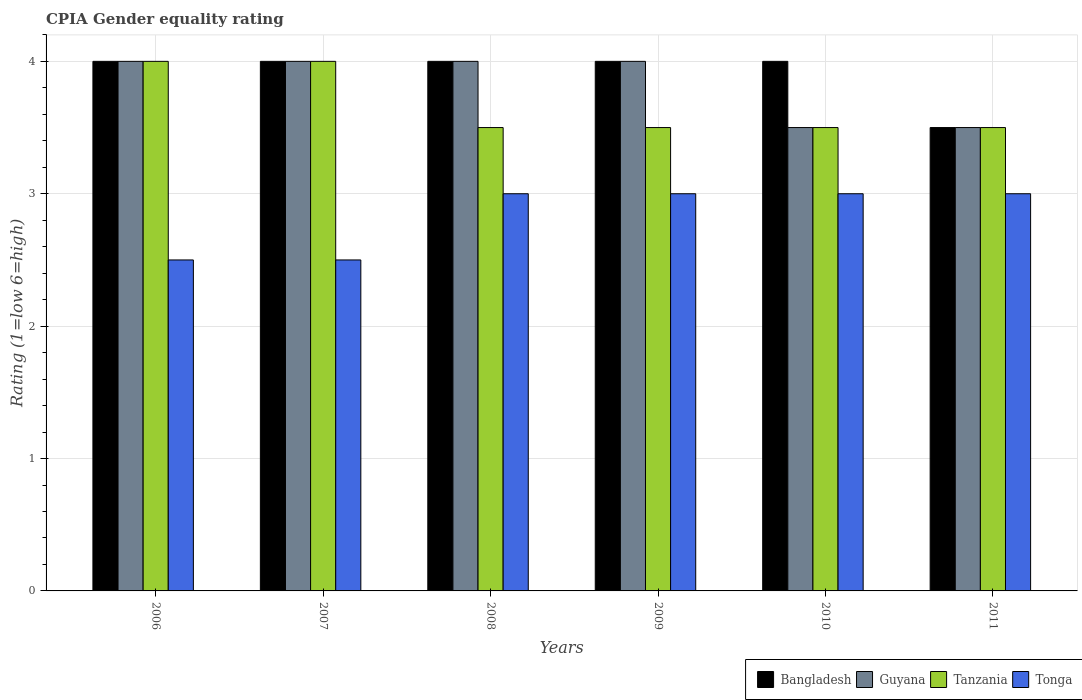Are the number of bars on each tick of the X-axis equal?
Give a very brief answer. Yes. What is the CPIA rating in Bangladesh in 2006?
Keep it short and to the point. 4. Across all years, what is the maximum CPIA rating in Guyana?
Provide a short and direct response. 4. Across all years, what is the minimum CPIA rating in Guyana?
Keep it short and to the point. 3.5. In which year was the CPIA rating in Guyana maximum?
Ensure brevity in your answer.  2006. What is the total CPIA rating in Tanzania in the graph?
Provide a short and direct response. 22. What is the difference between the CPIA rating in Guyana in 2006 and that in 2011?
Offer a terse response. 0.5. What is the difference between the CPIA rating in Guyana in 2008 and the CPIA rating in Tonga in 2009?
Offer a very short reply. 1. What is the average CPIA rating in Guyana per year?
Give a very brief answer. 3.83. In the year 2008, what is the difference between the CPIA rating in Bangladesh and CPIA rating in Tonga?
Offer a very short reply. 1. What is the ratio of the CPIA rating in Tonga in 2010 to that in 2011?
Offer a very short reply. 1. Is the difference between the CPIA rating in Bangladesh in 2008 and 2010 greater than the difference between the CPIA rating in Tonga in 2008 and 2010?
Provide a short and direct response. No. Is the sum of the CPIA rating in Guyana in 2006 and 2008 greater than the maximum CPIA rating in Tanzania across all years?
Your answer should be compact. Yes. What does the 4th bar from the left in 2006 represents?
Make the answer very short. Tonga. What does the 3rd bar from the right in 2009 represents?
Your response must be concise. Guyana. Is it the case that in every year, the sum of the CPIA rating in Guyana and CPIA rating in Bangladesh is greater than the CPIA rating in Tanzania?
Provide a succinct answer. Yes. How many bars are there?
Your answer should be very brief. 24. How many years are there in the graph?
Your answer should be very brief. 6. What is the difference between two consecutive major ticks on the Y-axis?
Give a very brief answer. 1. Does the graph contain any zero values?
Your answer should be compact. No. Does the graph contain grids?
Make the answer very short. Yes. Where does the legend appear in the graph?
Give a very brief answer. Bottom right. How many legend labels are there?
Offer a very short reply. 4. How are the legend labels stacked?
Your answer should be very brief. Horizontal. What is the title of the graph?
Your answer should be very brief. CPIA Gender equality rating. Does "Turkey" appear as one of the legend labels in the graph?
Your response must be concise. No. What is the label or title of the X-axis?
Your answer should be very brief. Years. What is the Rating (1=low 6=high) in Bangladesh in 2006?
Provide a succinct answer. 4. What is the Rating (1=low 6=high) in Guyana in 2006?
Ensure brevity in your answer.  4. What is the Rating (1=low 6=high) in Tonga in 2006?
Your answer should be compact. 2.5. What is the Rating (1=low 6=high) in Bangladesh in 2007?
Make the answer very short. 4. What is the Rating (1=low 6=high) in Guyana in 2007?
Your response must be concise. 4. What is the Rating (1=low 6=high) of Tonga in 2007?
Give a very brief answer. 2.5. What is the Rating (1=low 6=high) of Guyana in 2008?
Provide a short and direct response. 4. What is the Rating (1=low 6=high) of Guyana in 2009?
Your response must be concise. 4. What is the Rating (1=low 6=high) in Tanzania in 2010?
Provide a short and direct response. 3.5. What is the Rating (1=low 6=high) of Guyana in 2011?
Provide a succinct answer. 3.5. What is the Rating (1=low 6=high) of Tanzania in 2011?
Keep it short and to the point. 3.5. What is the Rating (1=low 6=high) in Tonga in 2011?
Provide a short and direct response. 3. Across all years, what is the maximum Rating (1=low 6=high) in Tonga?
Make the answer very short. 3. Across all years, what is the minimum Rating (1=low 6=high) in Guyana?
Make the answer very short. 3.5. What is the total Rating (1=low 6=high) of Bangladesh in the graph?
Offer a terse response. 23.5. What is the total Rating (1=low 6=high) of Guyana in the graph?
Offer a terse response. 23. What is the difference between the Rating (1=low 6=high) of Bangladesh in 2006 and that in 2007?
Offer a terse response. 0. What is the difference between the Rating (1=low 6=high) in Guyana in 2006 and that in 2007?
Give a very brief answer. 0. What is the difference between the Rating (1=low 6=high) in Tonga in 2006 and that in 2007?
Your answer should be very brief. 0. What is the difference between the Rating (1=low 6=high) in Bangladesh in 2006 and that in 2009?
Provide a succinct answer. 0. What is the difference between the Rating (1=low 6=high) of Guyana in 2006 and that in 2009?
Offer a terse response. 0. What is the difference between the Rating (1=low 6=high) in Tanzania in 2006 and that in 2009?
Keep it short and to the point. 0.5. What is the difference between the Rating (1=low 6=high) of Bangladesh in 2006 and that in 2010?
Your response must be concise. 0. What is the difference between the Rating (1=low 6=high) of Guyana in 2006 and that in 2010?
Offer a very short reply. 0.5. What is the difference between the Rating (1=low 6=high) in Tanzania in 2007 and that in 2009?
Ensure brevity in your answer.  0.5. What is the difference between the Rating (1=low 6=high) in Tanzania in 2007 and that in 2010?
Make the answer very short. 0.5. What is the difference between the Rating (1=low 6=high) in Tonga in 2007 and that in 2010?
Make the answer very short. -0.5. What is the difference between the Rating (1=low 6=high) in Bangladesh in 2007 and that in 2011?
Give a very brief answer. 0.5. What is the difference between the Rating (1=low 6=high) of Guyana in 2007 and that in 2011?
Your answer should be compact. 0.5. What is the difference between the Rating (1=low 6=high) in Guyana in 2008 and that in 2009?
Your response must be concise. 0. What is the difference between the Rating (1=low 6=high) in Tonga in 2008 and that in 2009?
Give a very brief answer. 0. What is the difference between the Rating (1=low 6=high) in Guyana in 2008 and that in 2010?
Provide a short and direct response. 0.5. What is the difference between the Rating (1=low 6=high) in Tanzania in 2008 and that in 2010?
Provide a succinct answer. 0. What is the difference between the Rating (1=low 6=high) in Bangladesh in 2008 and that in 2011?
Provide a succinct answer. 0.5. What is the difference between the Rating (1=low 6=high) in Tonga in 2008 and that in 2011?
Your response must be concise. 0. What is the difference between the Rating (1=low 6=high) in Bangladesh in 2009 and that in 2010?
Ensure brevity in your answer.  0. What is the difference between the Rating (1=low 6=high) in Guyana in 2009 and that in 2010?
Offer a terse response. 0.5. What is the difference between the Rating (1=low 6=high) in Tanzania in 2009 and that in 2010?
Your response must be concise. 0. What is the difference between the Rating (1=low 6=high) in Tonga in 2009 and that in 2010?
Offer a very short reply. 0. What is the difference between the Rating (1=low 6=high) of Guyana in 2009 and that in 2011?
Provide a succinct answer. 0.5. What is the difference between the Rating (1=low 6=high) of Tonga in 2009 and that in 2011?
Offer a very short reply. 0. What is the difference between the Rating (1=low 6=high) in Bangladesh in 2010 and that in 2011?
Give a very brief answer. 0.5. What is the difference between the Rating (1=low 6=high) in Tanzania in 2010 and that in 2011?
Your response must be concise. 0. What is the difference between the Rating (1=low 6=high) in Bangladesh in 2006 and the Rating (1=low 6=high) in Guyana in 2007?
Provide a short and direct response. 0. What is the difference between the Rating (1=low 6=high) in Bangladesh in 2006 and the Rating (1=low 6=high) in Tanzania in 2007?
Your answer should be compact. 0. What is the difference between the Rating (1=low 6=high) in Guyana in 2006 and the Rating (1=low 6=high) in Tanzania in 2007?
Keep it short and to the point. 0. What is the difference between the Rating (1=low 6=high) in Guyana in 2006 and the Rating (1=low 6=high) in Tonga in 2007?
Offer a terse response. 1.5. What is the difference between the Rating (1=low 6=high) of Bangladesh in 2006 and the Rating (1=low 6=high) of Guyana in 2008?
Give a very brief answer. 0. What is the difference between the Rating (1=low 6=high) of Bangladesh in 2006 and the Rating (1=low 6=high) of Tanzania in 2008?
Provide a short and direct response. 0.5. What is the difference between the Rating (1=low 6=high) of Bangladesh in 2006 and the Rating (1=low 6=high) of Tonga in 2008?
Keep it short and to the point. 1. What is the difference between the Rating (1=low 6=high) in Tanzania in 2006 and the Rating (1=low 6=high) in Tonga in 2008?
Make the answer very short. 1. What is the difference between the Rating (1=low 6=high) in Bangladesh in 2006 and the Rating (1=low 6=high) in Tanzania in 2009?
Provide a succinct answer. 0.5. What is the difference between the Rating (1=low 6=high) in Guyana in 2006 and the Rating (1=low 6=high) in Tonga in 2009?
Give a very brief answer. 1. What is the difference between the Rating (1=low 6=high) in Bangladesh in 2006 and the Rating (1=low 6=high) in Guyana in 2010?
Your answer should be compact. 0.5. What is the difference between the Rating (1=low 6=high) in Guyana in 2006 and the Rating (1=low 6=high) in Tonga in 2010?
Your response must be concise. 1. What is the difference between the Rating (1=low 6=high) in Tanzania in 2006 and the Rating (1=low 6=high) in Tonga in 2010?
Ensure brevity in your answer.  1. What is the difference between the Rating (1=low 6=high) in Bangladesh in 2006 and the Rating (1=low 6=high) in Tanzania in 2011?
Keep it short and to the point. 0.5. What is the difference between the Rating (1=low 6=high) of Bangladesh in 2007 and the Rating (1=low 6=high) of Guyana in 2008?
Ensure brevity in your answer.  0. What is the difference between the Rating (1=low 6=high) in Bangladesh in 2007 and the Rating (1=low 6=high) in Tanzania in 2008?
Make the answer very short. 0.5. What is the difference between the Rating (1=low 6=high) in Bangladesh in 2007 and the Rating (1=low 6=high) in Tonga in 2008?
Offer a very short reply. 1. What is the difference between the Rating (1=low 6=high) in Guyana in 2007 and the Rating (1=low 6=high) in Tanzania in 2008?
Your answer should be very brief. 0.5. What is the difference between the Rating (1=low 6=high) of Tanzania in 2007 and the Rating (1=low 6=high) of Tonga in 2008?
Offer a terse response. 1. What is the difference between the Rating (1=low 6=high) in Bangladesh in 2007 and the Rating (1=low 6=high) in Guyana in 2009?
Give a very brief answer. 0. What is the difference between the Rating (1=low 6=high) in Guyana in 2007 and the Rating (1=low 6=high) in Tanzania in 2009?
Ensure brevity in your answer.  0.5. What is the difference between the Rating (1=low 6=high) in Bangladesh in 2007 and the Rating (1=low 6=high) in Guyana in 2010?
Make the answer very short. 0.5. What is the difference between the Rating (1=low 6=high) of Bangladesh in 2007 and the Rating (1=low 6=high) of Tanzania in 2010?
Make the answer very short. 0.5. What is the difference between the Rating (1=low 6=high) in Bangladesh in 2007 and the Rating (1=low 6=high) in Tonga in 2010?
Offer a very short reply. 1. What is the difference between the Rating (1=low 6=high) of Guyana in 2007 and the Rating (1=low 6=high) of Tanzania in 2010?
Provide a short and direct response. 0.5. What is the difference between the Rating (1=low 6=high) in Tanzania in 2007 and the Rating (1=low 6=high) in Tonga in 2010?
Make the answer very short. 1. What is the difference between the Rating (1=low 6=high) of Bangladesh in 2007 and the Rating (1=low 6=high) of Tanzania in 2011?
Offer a terse response. 0.5. What is the difference between the Rating (1=low 6=high) in Bangladesh in 2007 and the Rating (1=low 6=high) in Tonga in 2011?
Your answer should be compact. 1. What is the difference between the Rating (1=low 6=high) of Tanzania in 2007 and the Rating (1=low 6=high) of Tonga in 2011?
Offer a very short reply. 1. What is the difference between the Rating (1=low 6=high) in Bangladesh in 2008 and the Rating (1=low 6=high) in Tanzania in 2009?
Offer a terse response. 0.5. What is the difference between the Rating (1=low 6=high) of Guyana in 2008 and the Rating (1=low 6=high) of Tanzania in 2009?
Give a very brief answer. 0.5. What is the difference between the Rating (1=low 6=high) in Tanzania in 2008 and the Rating (1=low 6=high) in Tonga in 2009?
Make the answer very short. 0.5. What is the difference between the Rating (1=low 6=high) in Guyana in 2008 and the Rating (1=low 6=high) in Tanzania in 2010?
Ensure brevity in your answer.  0.5. What is the difference between the Rating (1=low 6=high) in Bangladesh in 2008 and the Rating (1=low 6=high) in Guyana in 2011?
Your answer should be compact. 0.5. What is the difference between the Rating (1=low 6=high) in Bangladesh in 2008 and the Rating (1=low 6=high) in Tanzania in 2011?
Provide a succinct answer. 0.5. What is the difference between the Rating (1=low 6=high) in Tanzania in 2008 and the Rating (1=low 6=high) in Tonga in 2011?
Your answer should be compact. 0.5. What is the difference between the Rating (1=low 6=high) in Bangladesh in 2009 and the Rating (1=low 6=high) in Tonga in 2010?
Provide a succinct answer. 1. What is the difference between the Rating (1=low 6=high) in Tanzania in 2009 and the Rating (1=low 6=high) in Tonga in 2010?
Keep it short and to the point. 0.5. What is the difference between the Rating (1=low 6=high) in Bangladesh in 2009 and the Rating (1=low 6=high) in Tanzania in 2011?
Your answer should be compact. 0.5. What is the difference between the Rating (1=low 6=high) in Bangladesh in 2009 and the Rating (1=low 6=high) in Tonga in 2011?
Your response must be concise. 1. What is the difference between the Rating (1=low 6=high) in Guyana in 2009 and the Rating (1=low 6=high) in Tanzania in 2011?
Ensure brevity in your answer.  0.5. What is the difference between the Rating (1=low 6=high) in Guyana in 2009 and the Rating (1=low 6=high) in Tonga in 2011?
Your answer should be very brief. 1. What is the difference between the Rating (1=low 6=high) of Bangladesh in 2010 and the Rating (1=low 6=high) of Guyana in 2011?
Make the answer very short. 0.5. What is the difference between the Rating (1=low 6=high) in Bangladesh in 2010 and the Rating (1=low 6=high) in Tonga in 2011?
Your answer should be compact. 1. What is the difference between the Rating (1=low 6=high) of Guyana in 2010 and the Rating (1=low 6=high) of Tanzania in 2011?
Give a very brief answer. 0. What is the difference between the Rating (1=low 6=high) of Guyana in 2010 and the Rating (1=low 6=high) of Tonga in 2011?
Ensure brevity in your answer.  0.5. What is the difference between the Rating (1=low 6=high) of Tanzania in 2010 and the Rating (1=low 6=high) of Tonga in 2011?
Your response must be concise. 0.5. What is the average Rating (1=low 6=high) in Bangladesh per year?
Make the answer very short. 3.92. What is the average Rating (1=low 6=high) of Guyana per year?
Your answer should be very brief. 3.83. What is the average Rating (1=low 6=high) of Tanzania per year?
Ensure brevity in your answer.  3.67. What is the average Rating (1=low 6=high) in Tonga per year?
Your answer should be compact. 2.83. In the year 2006, what is the difference between the Rating (1=low 6=high) in Bangladesh and Rating (1=low 6=high) in Tanzania?
Make the answer very short. 0. In the year 2006, what is the difference between the Rating (1=low 6=high) of Guyana and Rating (1=low 6=high) of Tanzania?
Offer a terse response. 0. In the year 2006, what is the difference between the Rating (1=low 6=high) in Guyana and Rating (1=low 6=high) in Tonga?
Provide a succinct answer. 1.5. In the year 2006, what is the difference between the Rating (1=low 6=high) of Tanzania and Rating (1=low 6=high) of Tonga?
Your response must be concise. 1.5. In the year 2007, what is the difference between the Rating (1=low 6=high) of Guyana and Rating (1=low 6=high) of Tonga?
Make the answer very short. 1.5. In the year 2008, what is the difference between the Rating (1=low 6=high) in Bangladesh and Rating (1=low 6=high) in Tanzania?
Offer a very short reply. 0.5. In the year 2008, what is the difference between the Rating (1=low 6=high) of Bangladesh and Rating (1=low 6=high) of Tonga?
Provide a short and direct response. 1. In the year 2008, what is the difference between the Rating (1=low 6=high) in Guyana and Rating (1=low 6=high) in Tanzania?
Keep it short and to the point. 0.5. In the year 2009, what is the difference between the Rating (1=low 6=high) of Bangladesh and Rating (1=low 6=high) of Guyana?
Provide a short and direct response. 0. In the year 2009, what is the difference between the Rating (1=low 6=high) in Guyana and Rating (1=low 6=high) in Tonga?
Ensure brevity in your answer.  1. In the year 2009, what is the difference between the Rating (1=low 6=high) in Tanzania and Rating (1=low 6=high) in Tonga?
Give a very brief answer. 0.5. In the year 2010, what is the difference between the Rating (1=low 6=high) of Bangladesh and Rating (1=low 6=high) of Tanzania?
Offer a very short reply. 0.5. In the year 2010, what is the difference between the Rating (1=low 6=high) of Guyana and Rating (1=low 6=high) of Tanzania?
Offer a very short reply. 0. In the year 2010, what is the difference between the Rating (1=low 6=high) of Guyana and Rating (1=low 6=high) of Tonga?
Make the answer very short. 0.5. In the year 2010, what is the difference between the Rating (1=low 6=high) of Tanzania and Rating (1=low 6=high) of Tonga?
Provide a succinct answer. 0.5. In the year 2011, what is the difference between the Rating (1=low 6=high) in Guyana and Rating (1=low 6=high) in Tanzania?
Offer a very short reply. 0. In the year 2011, what is the difference between the Rating (1=low 6=high) in Tanzania and Rating (1=low 6=high) in Tonga?
Make the answer very short. 0.5. What is the ratio of the Rating (1=low 6=high) in Bangladesh in 2006 to that in 2007?
Offer a terse response. 1. What is the ratio of the Rating (1=low 6=high) in Tonga in 2006 to that in 2007?
Your answer should be very brief. 1. What is the ratio of the Rating (1=low 6=high) in Tonga in 2006 to that in 2009?
Your answer should be compact. 0.83. What is the ratio of the Rating (1=low 6=high) in Bangladesh in 2006 to that in 2011?
Your answer should be compact. 1.14. What is the ratio of the Rating (1=low 6=high) of Tonga in 2006 to that in 2011?
Provide a succinct answer. 0.83. What is the ratio of the Rating (1=low 6=high) of Bangladesh in 2007 to that in 2008?
Your response must be concise. 1. What is the ratio of the Rating (1=low 6=high) in Guyana in 2007 to that in 2008?
Provide a short and direct response. 1. What is the ratio of the Rating (1=low 6=high) in Tanzania in 2007 to that in 2008?
Your answer should be compact. 1.14. What is the ratio of the Rating (1=low 6=high) in Tonga in 2007 to that in 2008?
Your response must be concise. 0.83. What is the ratio of the Rating (1=low 6=high) in Bangladesh in 2007 to that in 2009?
Give a very brief answer. 1. What is the ratio of the Rating (1=low 6=high) of Guyana in 2007 to that in 2009?
Your response must be concise. 1. What is the ratio of the Rating (1=low 6=high) of Tonga in 2007 to that in 2009?
Your answer should be very brief. 0.83. What is the ratio of the Rating (1=low 6=high) of Guyana in 2007 to that in 2010?
Offer a very short reply. 1.14. What is the ratio of the Rating (1=low 6=high) in Tonga in 2007 to that in 2010?
Ensure brevity in your answer.  0.83. What is the ratio of the Rating (1=low 6=high) in Bangladesh in 2007 to that in 2011?
Provide a succinct answer. 1.14. What is the ratio of the Rating (1=low 6=high) of Guyana in 2007 to that in 2011?
Provide a succinct answer. 1.14. What is the ratio of the Rating (1=low 6=high) in Tanzania in 2007 to that in 2011?
Offer a very short reply. 1.14. What is the ratio of the Rating (1=low 6=high) in Tonga in 2007 to that in 2011?
Offer a terse response. 0.83. What is the ratio of the Rating (1=low 6=high) in Guyana in 2008 to that in 2009?
Your answer should be very brief. 1. What is the ratio of the Rating (1=low 6=high) of Tanzania in 2008 to that in 2009?
Your answer should be compact. 1. What is the ratio of the Rating (1=low 6=high) of Bangladesh in 2008 to that in 2010?
Offer a very short reply. 1. What is the ratio of the Rating (1=low 6=high) in Guyana in 2008 to that in 2010?
Your answer should be compact. 1.14. What is the ratio of the Rating (1=low 6=high) in Tonga in 2008 to that in 2010?
Ensure brevity in your answer.  1. What is the ratio of the Rating (1=low 6=high) of Bangladesh in 2008 to that in 2011?
Keep it short and to the point. 1.14. What is the ratio of the Rating (1=low 6=high) of Tanzania in 2008 to that in 2011?
Ensure brevity in your answer.  1. What is the ratio of the Rating (1=low 6=high) of Tonga in 2009 to that in 2010?
Give a very brief answer. 1. What is the ratio of the Rating (1=low 6=high) of Guyana in 2009 to that in 2011?
Offer a terse response. 1.14. What is the ratio of the Rating (1=low 6=high) of Tanzania in 2009 to that in 2011?
Offer a very short reply. 1. What is the ratio of the Rating (1=low 6=high) in Bangladesh in 2010 to that in 2011?
Keep it short and to the point. 1.14. What is the ratio of the Rating (1=low 6=high) in Guyana in 2010 to that in 2011?
Ensure brevity in your answer.  1. What is the ratio of the Rating (1=low 6=high) in Tanzania in 2010 to that in 2011?
Your response must be concise. 1. What is the difference between the highest and the second highest Rating (1=low 6=high) of Bangladesh?
Your answer should be very brief. 0. What is the difference between the highest and the second highest Rating (1=low 6=high) in Guyana?
Provide a short and direct response. 0. What is the difference between the highest and the second highest Rating (1=low 6=high) in Tonga?
Your response must be concise. 0. What is the difference between the highest and the lowest Rating (1=low 6=high) of Bangladesh?
Offer a terse response. 0.5. What is the difference between the highest and the lowest Rating (1=low 6=high) in Tanzania?
Offer a very short reply. 0.5. What is the difference between the highest and the lowest Rating (1=low 6=high) of Tonga?
Ensure brevity in your answer.  0.5. 